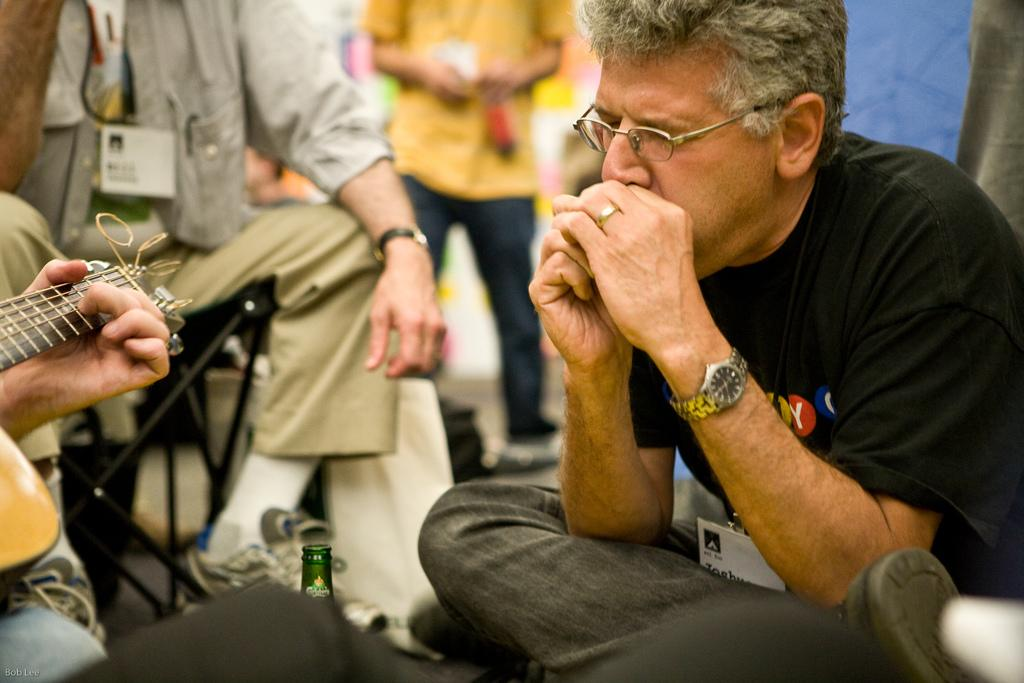What is the person in the image doing? There is a person sitting in the image. Can you describe the person's appearance? The person is wearing eyeglasses. What object is visible in the image besides the person? There is a guitar in the image. How many people are present in the image? There are other people in the image. What is located at the bottom of the image? There is a bottle at the bottom of the image. What type of sock is the person wearing in the image? There is no mention of a sock in the image, so it cannot be determined what type of sock the person is wearing. 